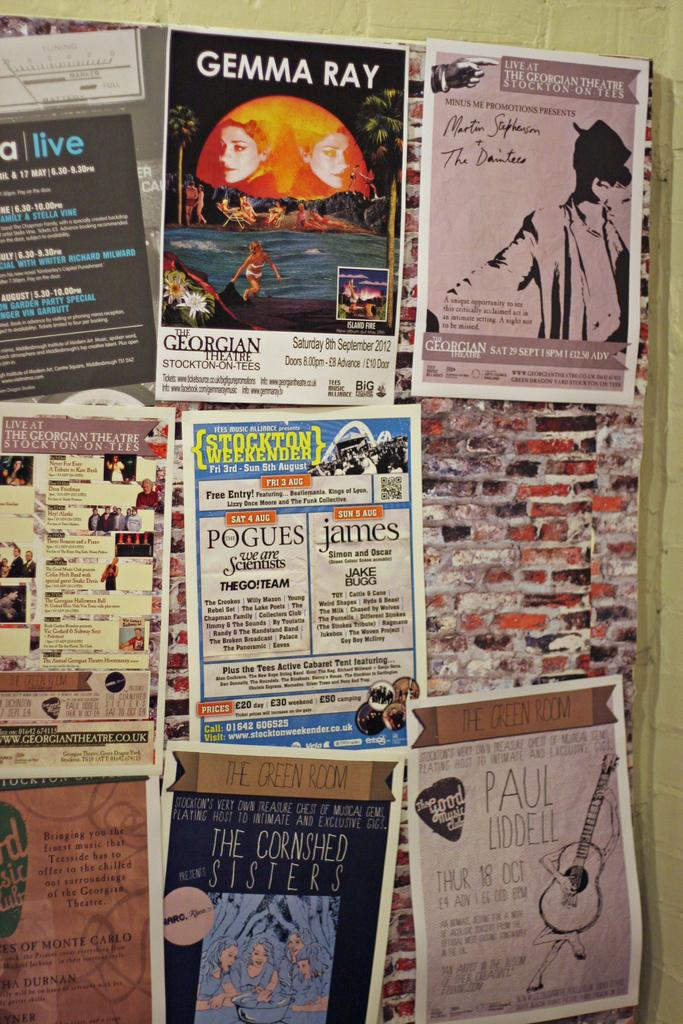<image>
Create a compact narrative representing the image presented. A group of papers stuck against a wall, with one being for an event titled Gemma Ray. 